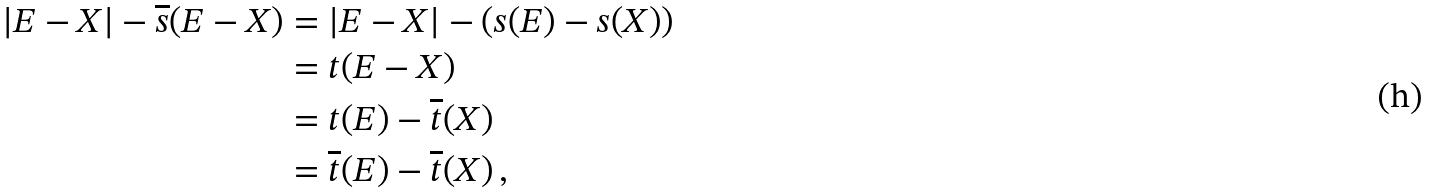<formula> <loc_0><loc_0><loc_500><loc_500>| E - X | - \overline { s } ( E - X ) & = | E - X | - ( s ( E ) - s ( X ) ) \\ & = t ( E - X ) \\ & = t ( E ) - \overline { t } ( X ) \\ & = \overline { t } ( E ) - \overline { t } ( X ) \, ,</formula> 